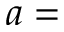Convert formula to latex. <formula><loc_0><loc_0><loc_500><loc_500>a =</formula> 